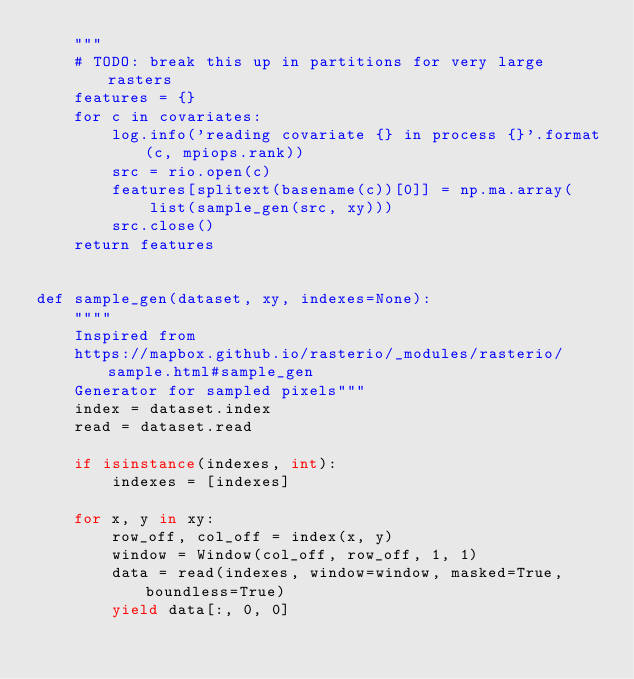<code> <loc_0><loc_0><loc_500><loc_500><_Python_>    """
    # TODO: break this up in partitions for very large rasters
    features = {}
    for c in covariates:
        log.info('reading covariate {} in process {}'.format(c, mpiops.rank))
        src = rio.open(c)
        features[splitext(basename(c))[0]] = np.ma.array(
            list(sample_gen(src, xy)))
        src.close()
    return features


def sample_gen(dataset, xy, indexes=None):
    """"
    Inspired from
    https://mapbox.github.io/rasterio/_modules/rasterio/sample.html#sample_gen
    Generator for sampled pixels"""
    index = dataset.index
    read = dataset.read

    if isinstance(indexes, int):
        indexes = [indexes]

    for x, y in xy:
        row_off, col_off = index(x, y)
        window = Window(col_off, row_off, 1, 1)
        data = read(indexes, window=window, masked=True, boundless=True)
        yield data[:, 0, 0]
</code> 